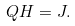<formula> <loc_0><loc_0><loc_500><loc_500>Q H = J .</formula> 